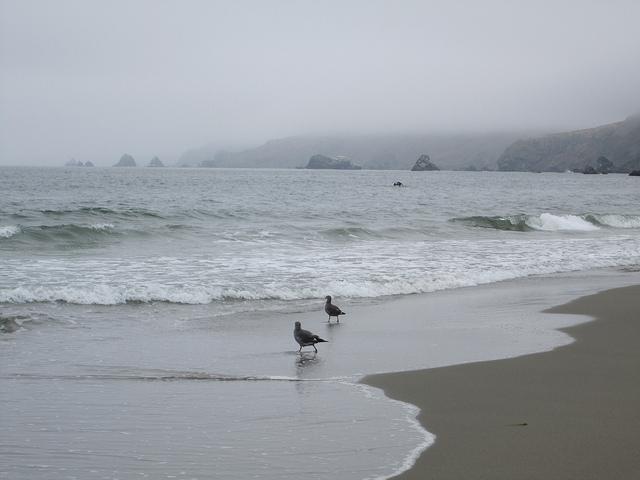Where are two birds walking?
Write a very short answer. Beach. Where is the ship?
Write a very short answer. In ocean. Was the bird suppose to be in the picture?
Write a very short answer. Yes. Is it sunny?
Quick response, please. No. 